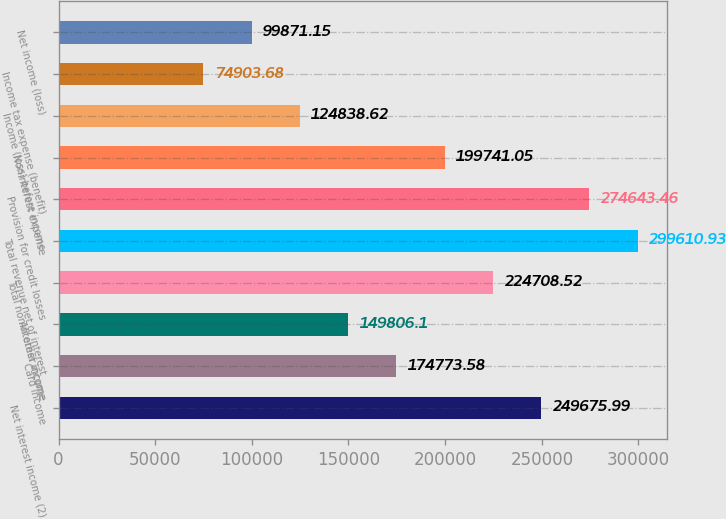Convert chart to OTSL. <chart><loc_0><loc_0><loc_500><loc_500><bar_chart><fcel>Net interest income (2)<fcel>Card income<fcel>All other income<fcel>Total noninterest income<fcel>Total revenue net of interest<fcel>Provision for credit losses<fcel>Noninterest expense<fcel>Income (loss) before income<fcel>Income tax expense (benefit)<fcel>Net income (loss)<nl><fcel>249676<fcel>174774<fcel>149806<fcel>224709<fcel>299611<fcel>274643<fcel>199741<fcel>124839<fcel>74903.7<fcel>99871.1<nl></chart> 